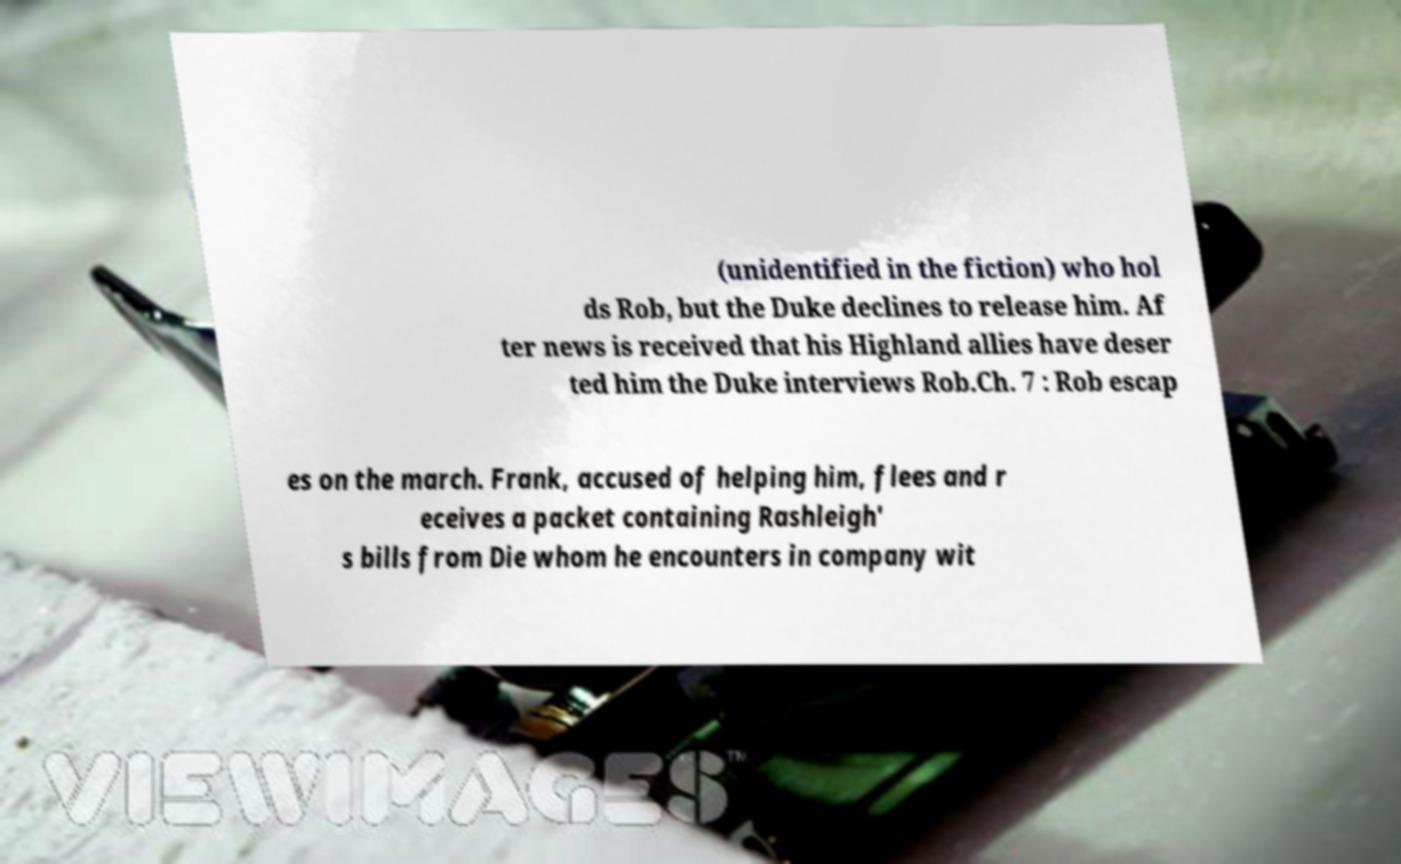There's text embedded in this image that I need extracted. Can you transcribe it verbatim? (unidentified in the fiction) who hol ds Rob, but the Duke declines to release him. Af ter news is received that his Highland allies have deser ted him the Duke interviews Rob.Ch. 7 : Rob escap es on the march. Frank, accused of helping him, flees and r eceives a packet containing Rashleigh' s bills from Die whom he encounters in company wit 